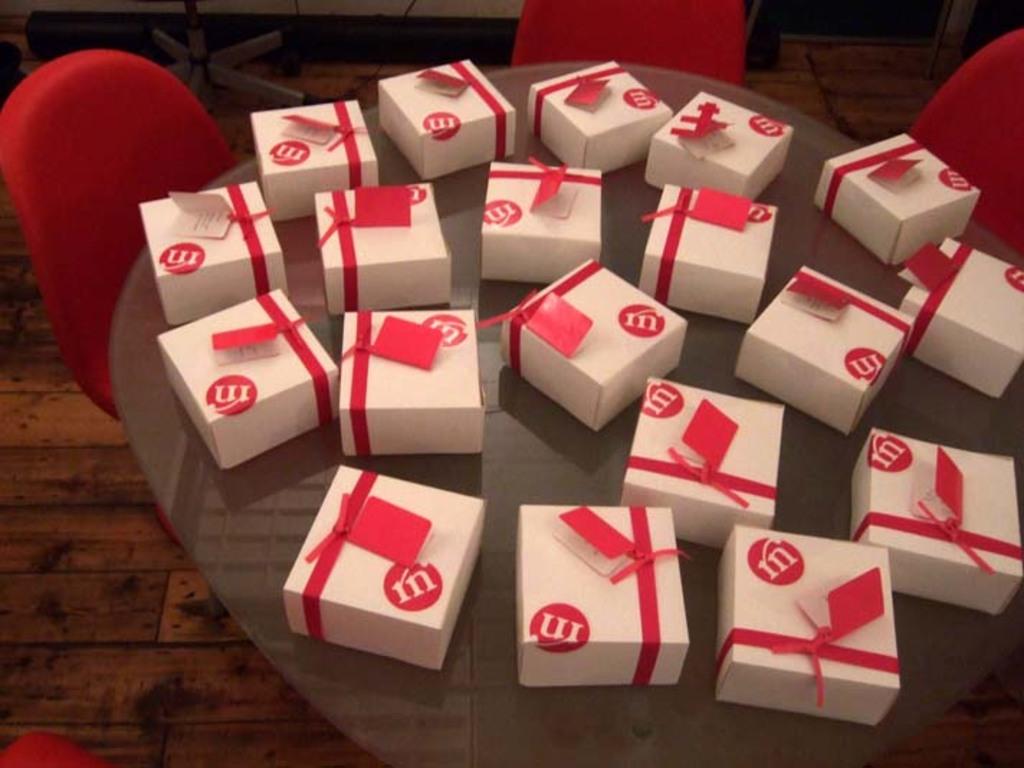What letter is written on all the boxes?
Keep it short and to the point. M. 